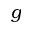<formula> <loc_0><loc_0><loc_500><loc_500>g</formula> 